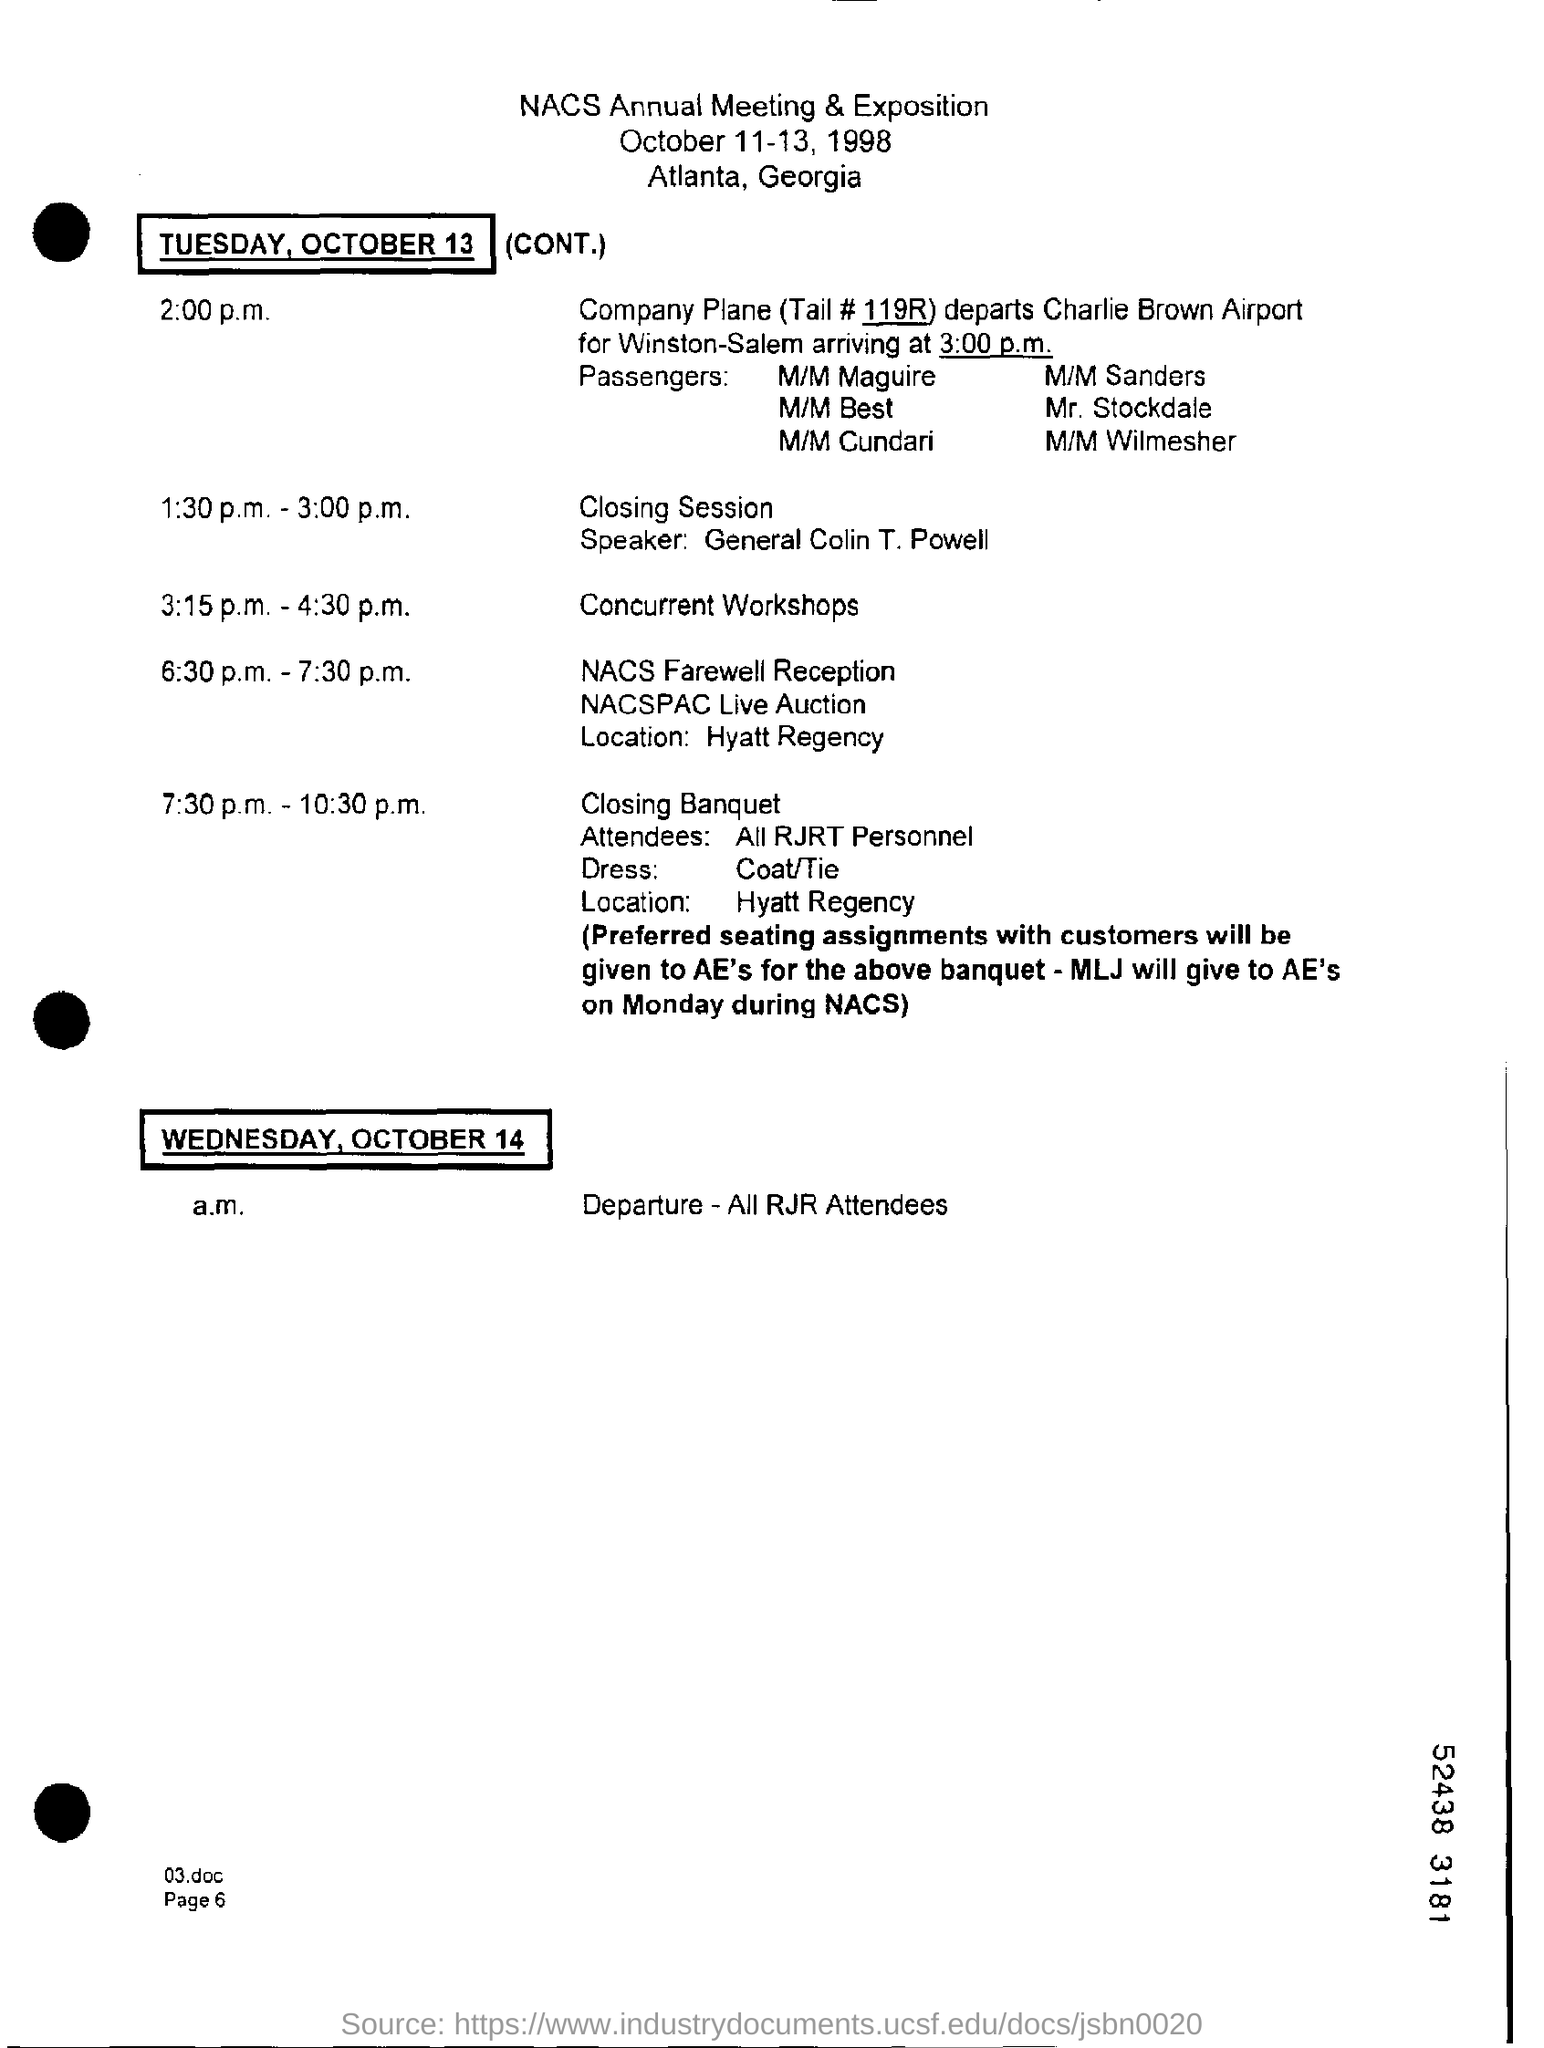Identify some key points in this picture. The concurrent workshops are scheduled to take place from 3:15 p.m. to 4:30 p.m. On October 14th, the departure of all RJR attendees is scheduled. The speaker for the closing session is General Colin T. Powell. The closing banquet is scheduled to take place from 7:30 p.m. to 10:30 p.m. The NACS Farewell Reception is held at the Hyatt Regency. 